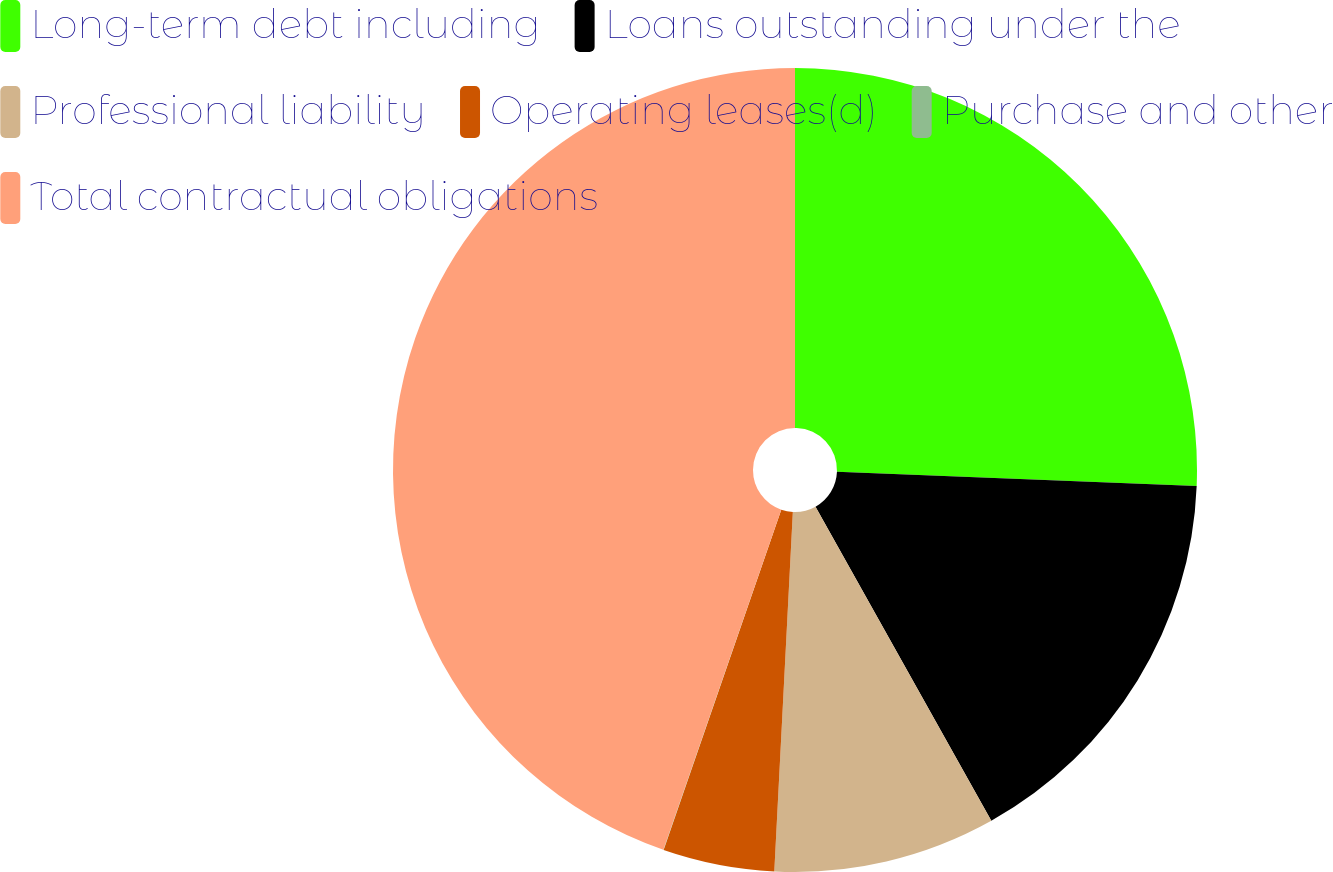Convert chart to OTSL. <chart><loc_0><loc_0><loc_500><loc_500><pie_chart><fcel>Long-term debt including<fcel>Loans outstanding under the<fcel>Professional liability<fcel>Operating leases(d)<fcel>Purchase and other<fcel>Total contractual obligations<nl><fcel>25.63%<fcel>16.25%<fcel>8.94%<fcel>4.48%<fcel>0.01%<fcel>44.69%<nl></chart> 